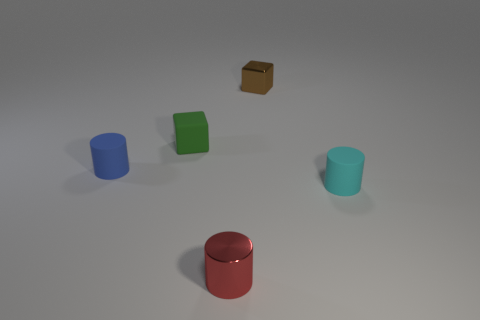Add 1 shiny cubes. How many objects exist? 6 Subtract all cylinders. How many objects are left? 2 Add 5 red cylinders. How many red cylinders are left? 6 Add 2 large purple objects. How many large purple objects exist? 2 Subtract 0 green cylinders. How many objects are left? 5 Subtract all small gray metal cylinders. Subtract all metallic cylinders. How many objects are left? 4 